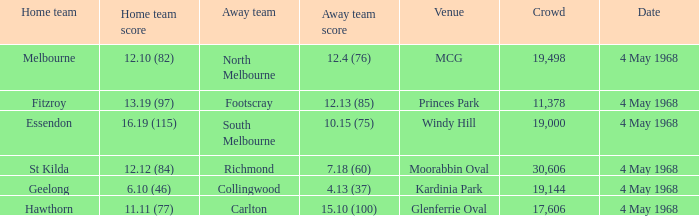What team played at Moorabbin Oval to a crowd of 19,144? St Kilda. 